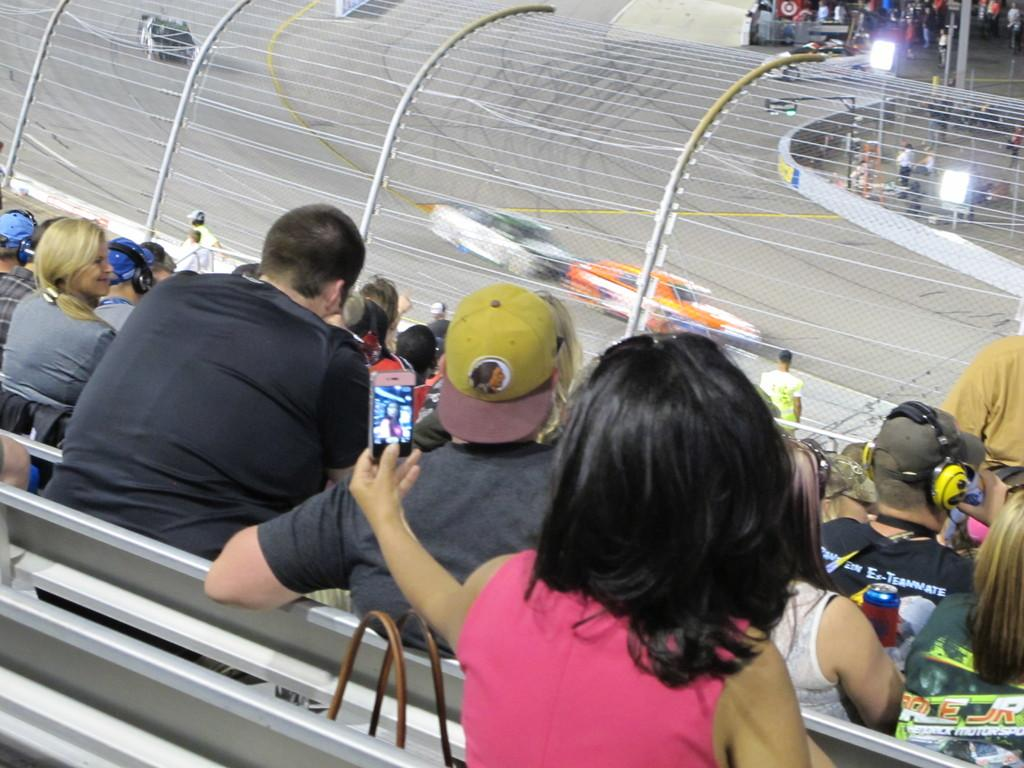What type of venue is shown in the image? There is a stadium present in the image. What are the people in the stadium doing? There are many persons sitting in the stadium, suggesting they are attending an event. What kind of event might be taking place in the image? It appears to be a car racing event. Can you describe the woman at the bottom of the image? The woman is taking a selfie picture. What flavor of mint can be seen in the image? There is no mint present in the image. What unit of measurement is used to determine the speed of the cars in the image? The image does not provide information about the speed of the cars or any units of measurement. 